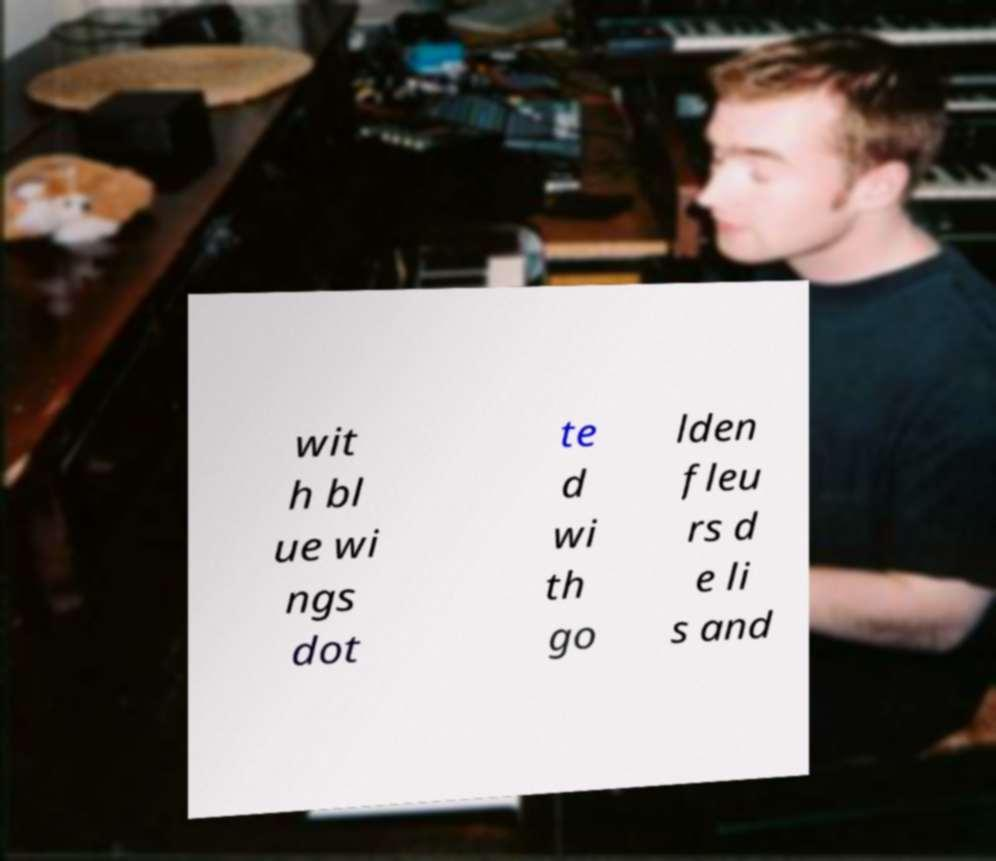Can you read and provide the text displayed in the image?This photo seems to have some interesting text. Can you extract and type it out for me? wit h bl ue wi ngs dot te d wi th go lden fleu rs d e li s and 